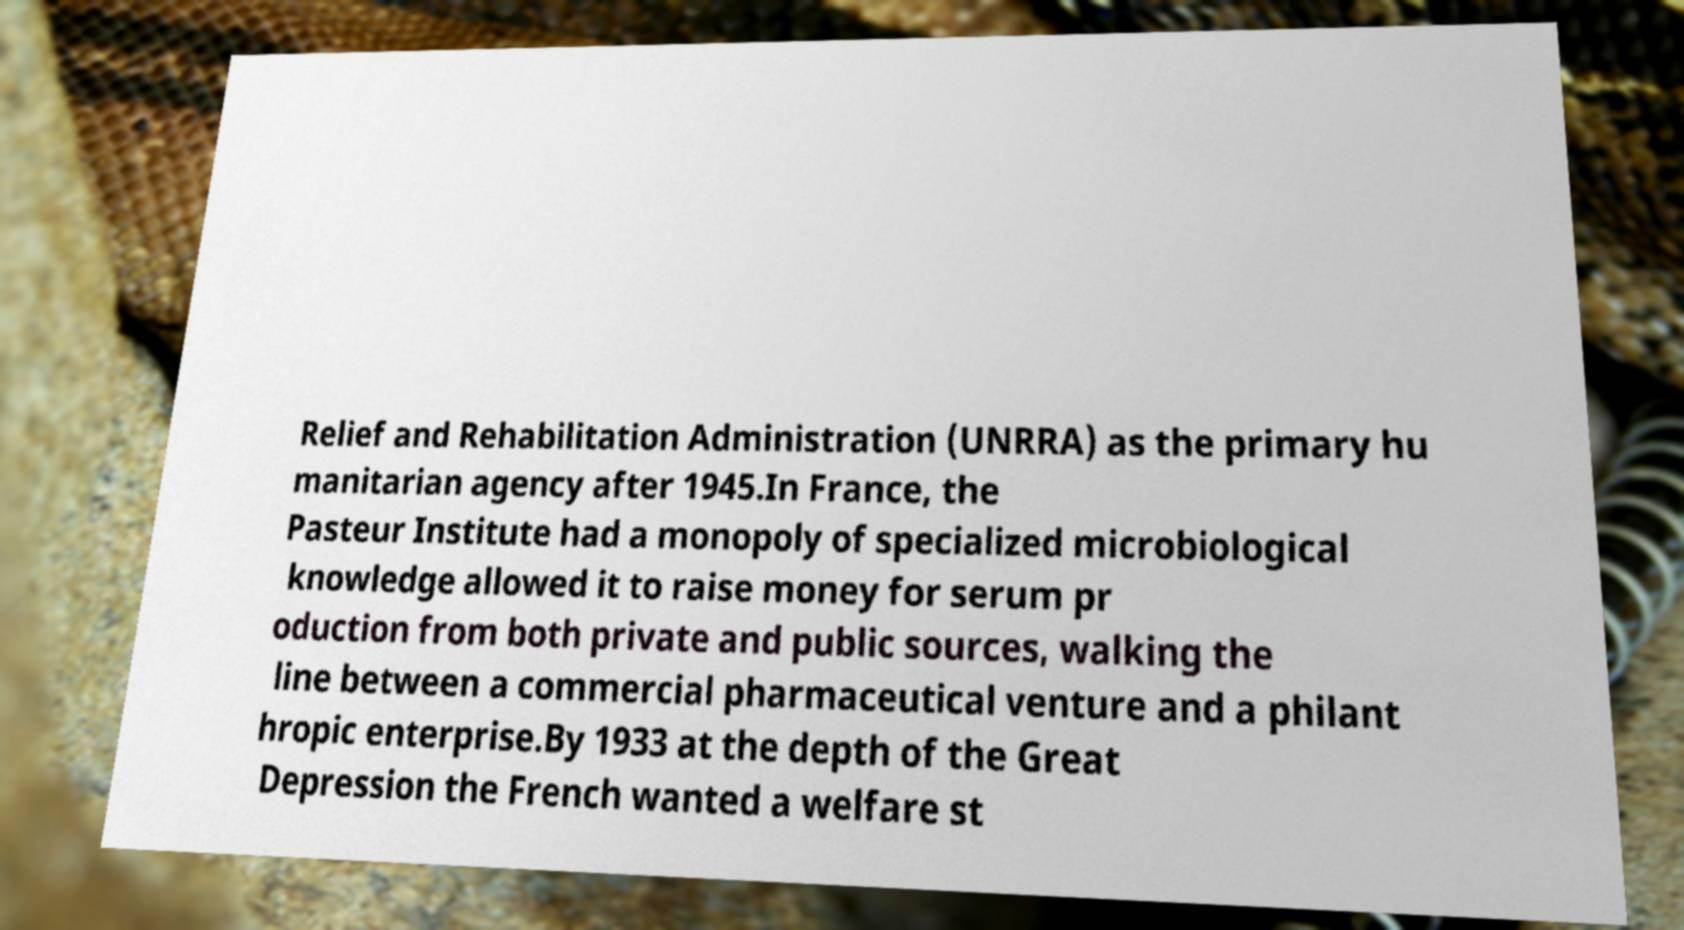There's text embedded in this image that I need extracted. Can you transcribe it verbatim? Relief and Rehabilitation Administration (UNRRA) as the primary hu manitarian agency after 1945.In France, the Pasteur Institute had a monopoly of specialized microbiological knowledge allowed it to raise money for serum pr oduction from both private and public sources, walking the line between a commercial pharmaceutical venture and a philant hropic enterprise.By 1933 at the depth of the Great Depression the French wanted a welfare st 